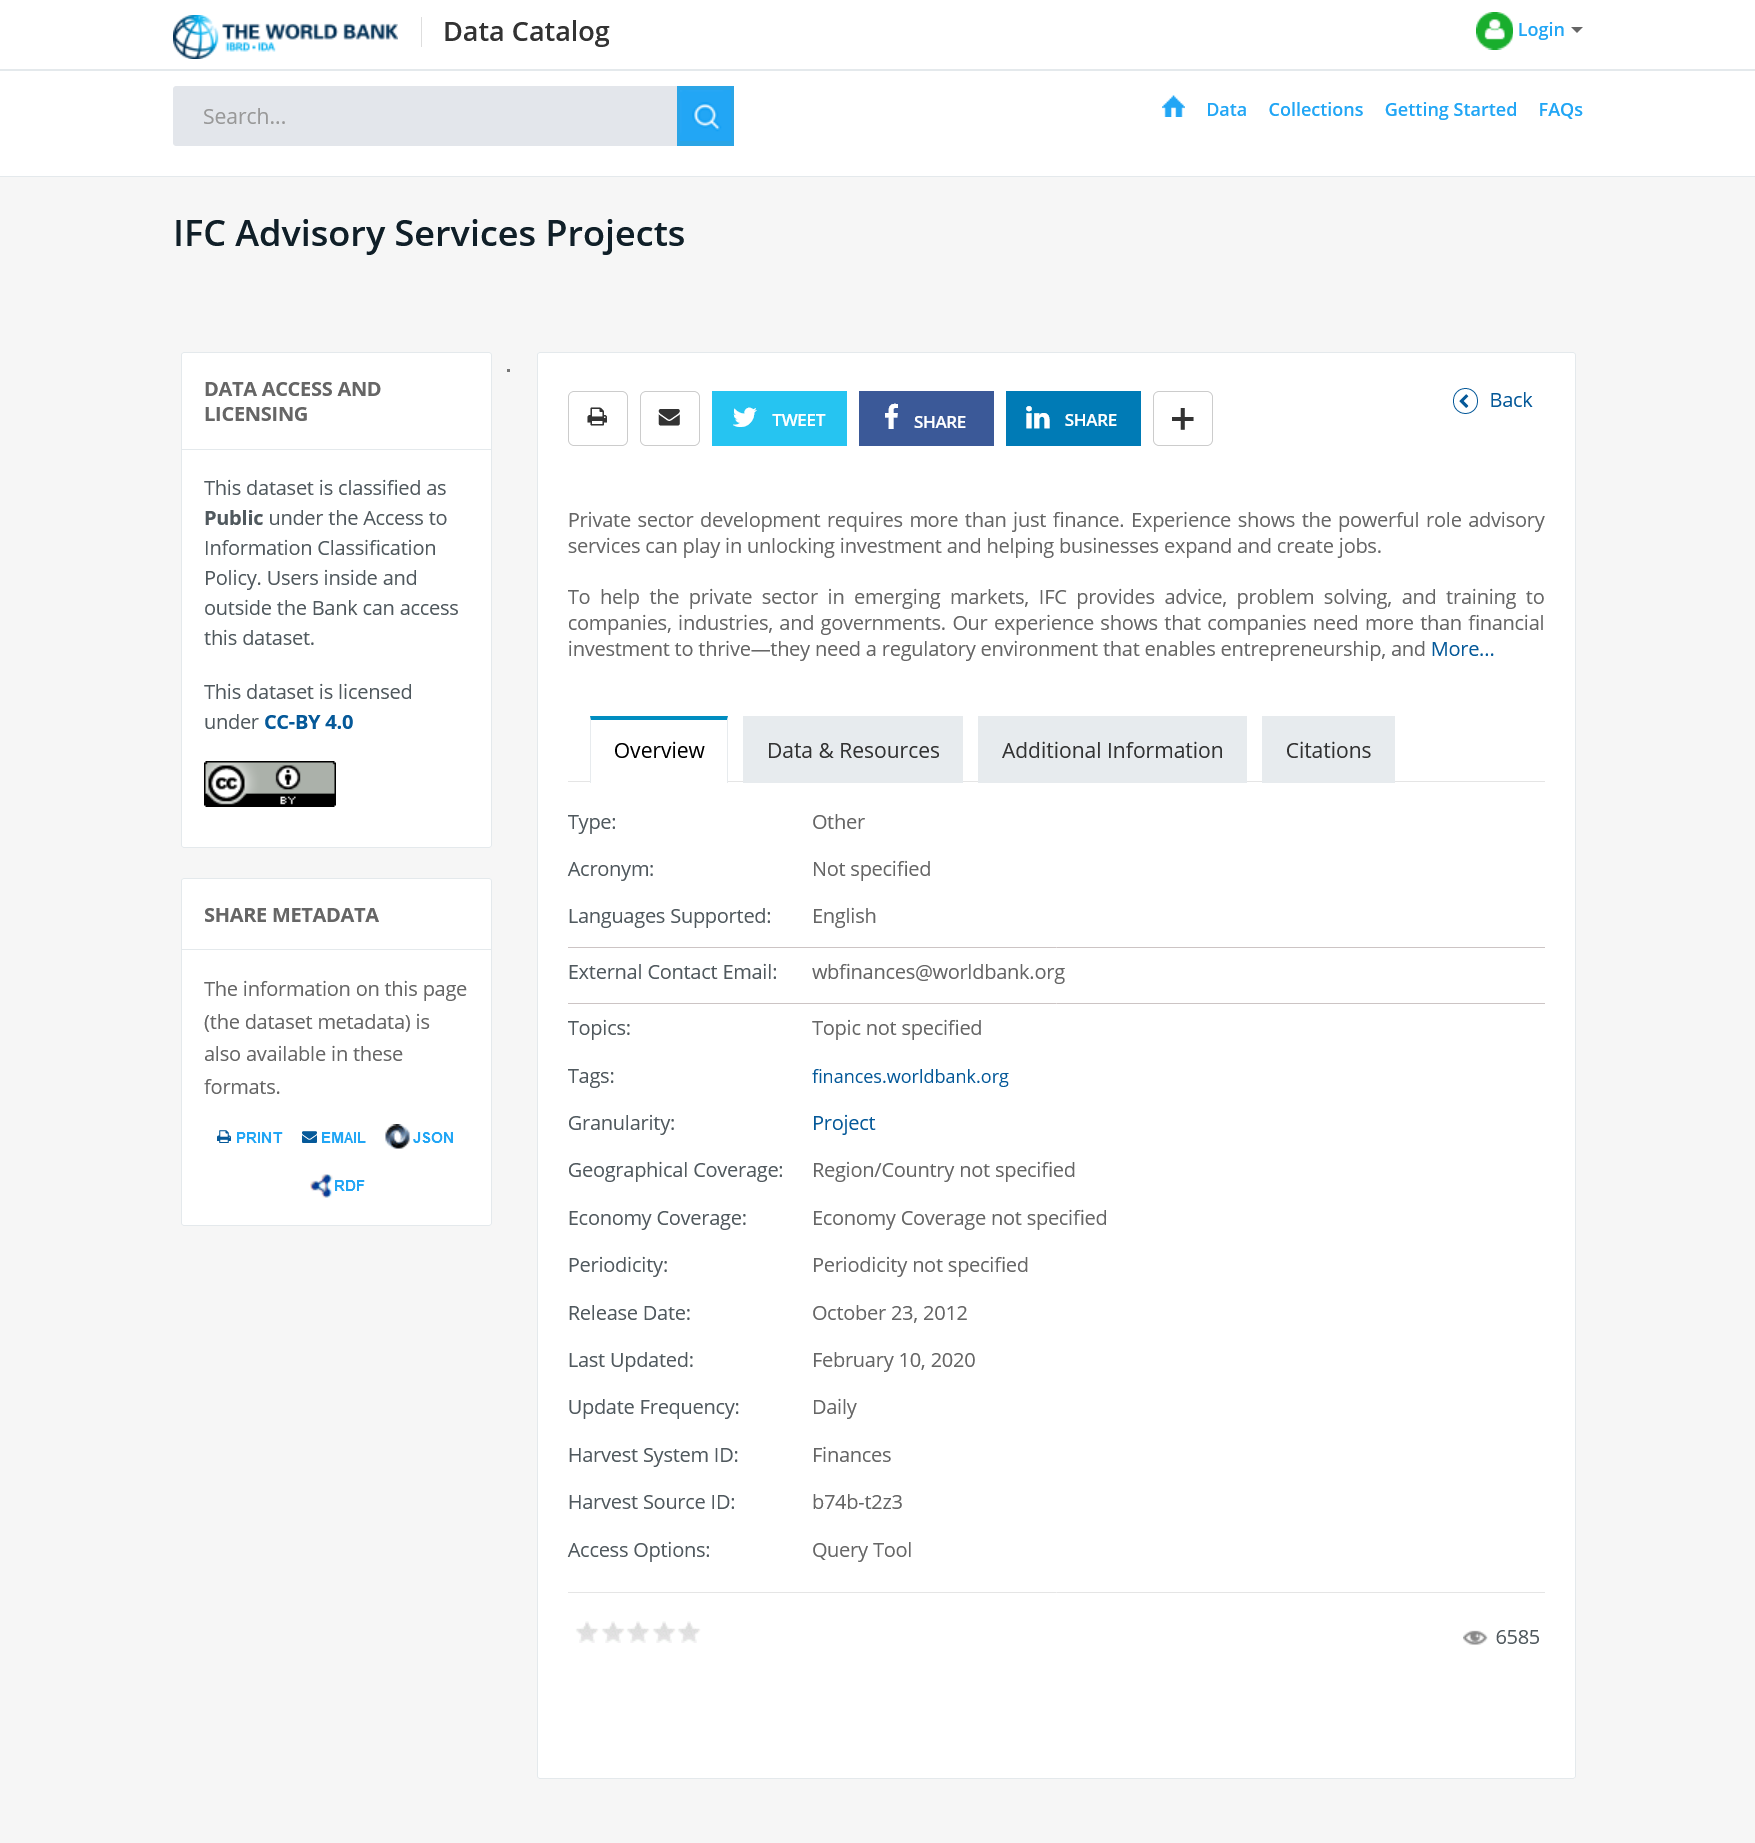List a handful of essential elements in this visual. The International Finance Corporation (IFC) provides the private sector with advice, problem-solving services, and training to companies, industries, and governments worldwide. IFC Advisory Services Projects serve the private sector in various sectors. The dataset is classified as public under the Access to Information Classification Policy. 